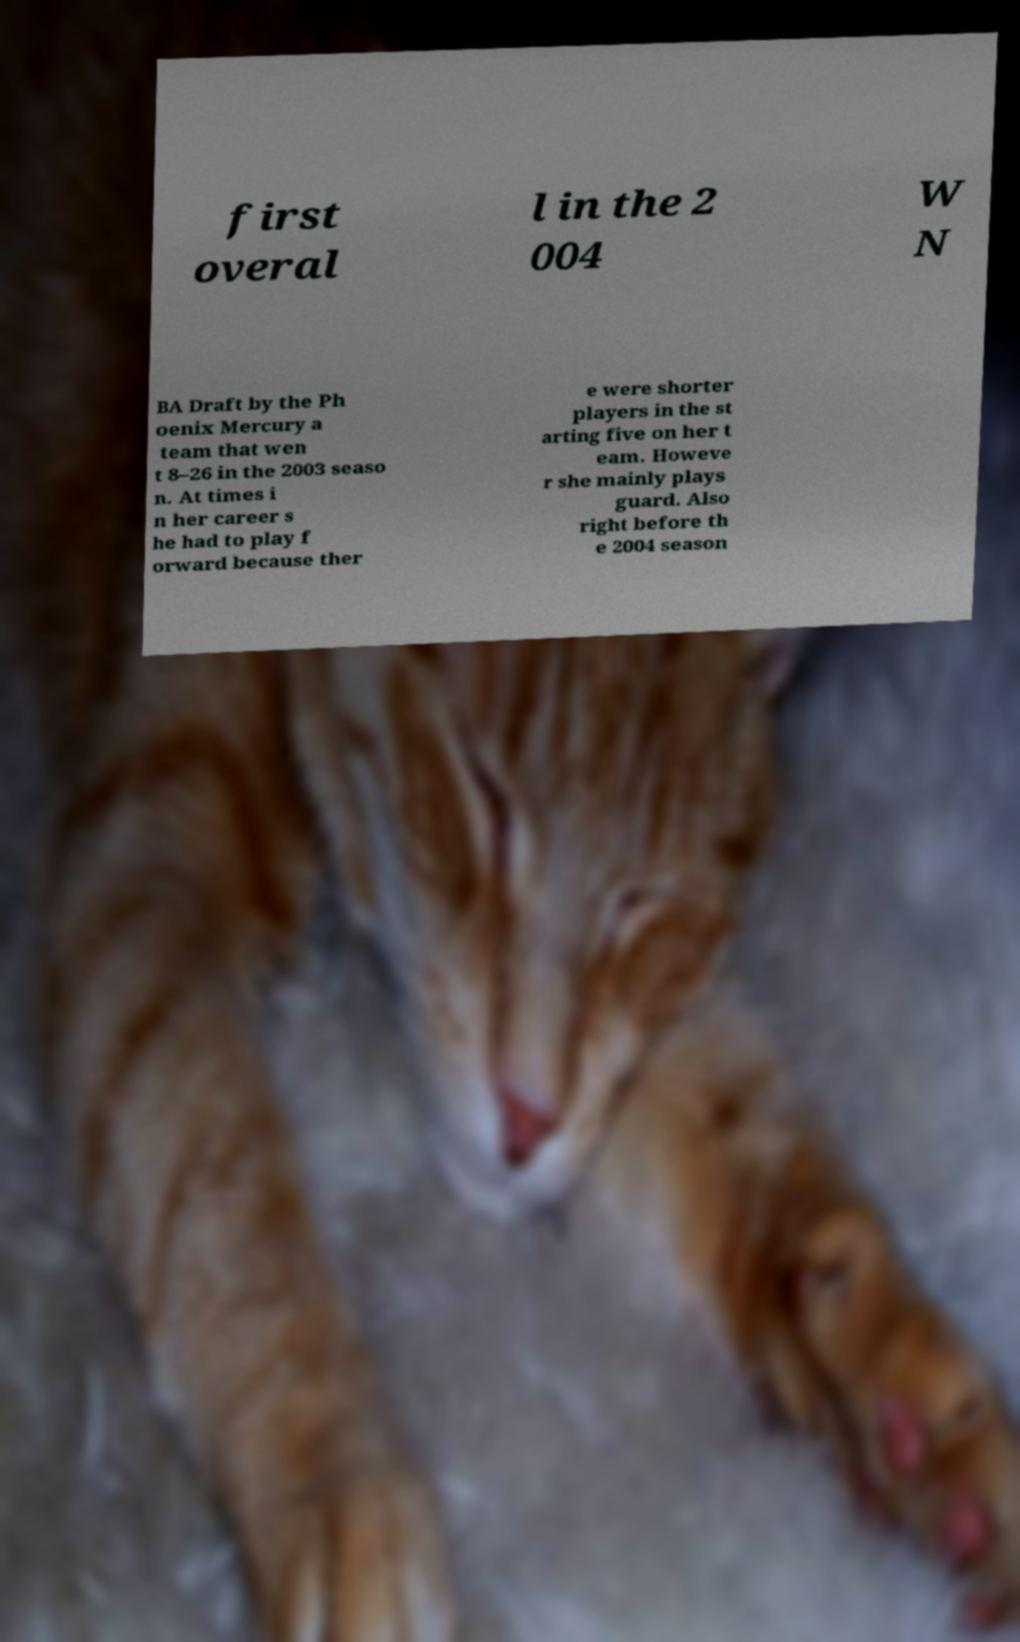There's text embedded in this image that I need extracted. Can you transcribe it verbatim? first overal l in the 2 004 W N BA Draft by the Ph oenix Mercury a team that wen t 8–26 in the 2003 seaso n. At times i n her career s he had to play f orward because ther e were shorter players in the st arting five on her t eam. Howeve r she mainly plays guard. Also right before th e 2004 season 